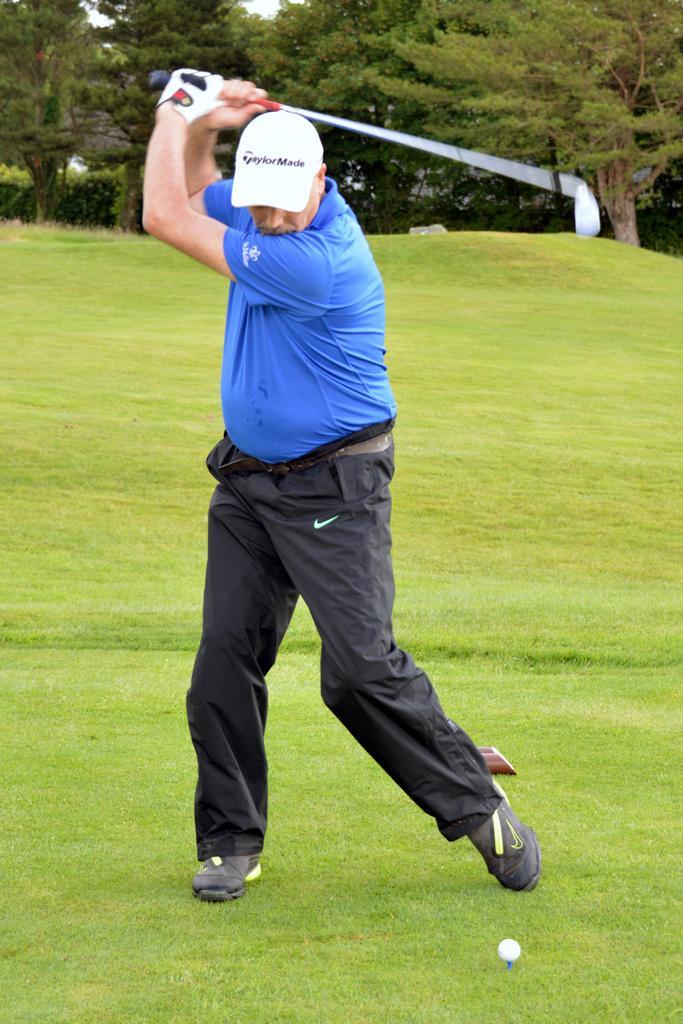Describe this image in one or two sentences. In the image we can see a man standing, wearing clothes, cap, shoes and a glove. There is a golf stick and golf ball, grass and there are many trees. 